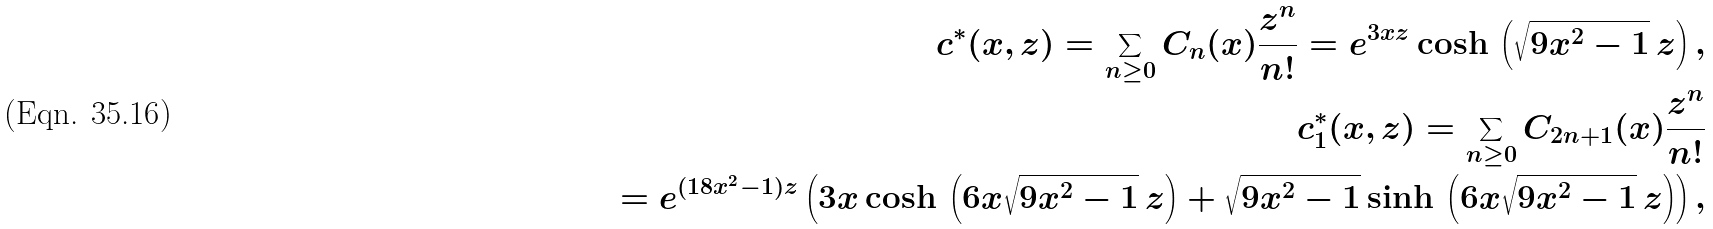Convert formula to latex. <formula><loc_0><loc_0><loc_500><loc_500>c ^ { * } ( x , z ) = \sum _ { n \geq 0 } C _ { n } ( x ) \frac { z ^ { n } } { n ! } = e ^ { 3 x z } \cosh \, \left ( \sqrt { 9 x ^ { 2 } - 1 } \, z \right ) , \\ c ^ { * } _ { 1 } ( x , z ) = \sum _ { n \geq 0 } C _ { 2 n + 1 } ( x ) \frac { z ^ { n } } { n ! } \\ = e ^ { ( 1 8 x ^ { 2 } - 1 ) z } \left ( 3 x \cosh \, \left ( 6 x \sqrt { 9 x ^ { 2 } - 1 } \, z \right ) + \sqrt { 9 x ^ { 2 } - 1 } \sinh \, \left ( 6 x \sqrt { 9 x ^ { 2 } - 1 } \, z \right ) \right ) ,</formula> 